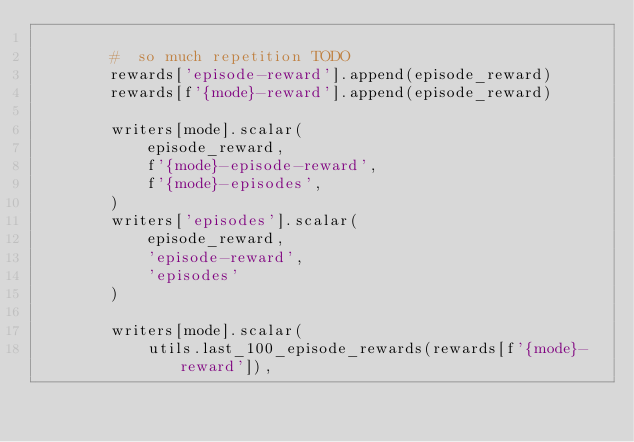<code> <loc_0><loc_0><loc_500><loc_500><_Python_>
        #  so much repetition TODO
        rewards['episode-reward'].append(episode_reward)
        rewards[f'{mode}-reward'].append(episode_reward)

        writers[mode].scalar(
            episode_reward,
            f'{mode}-episode-reward',
            f'{mode}-episodes',
        )
        writers['episodes'].scalar(
            episode_reward,
            'episode-reward',
            'episodes'
        )

        writers[mode].scalar(
            utils.last_100_episode_rewards(rewards[f'{mode}-reward']),</code> 